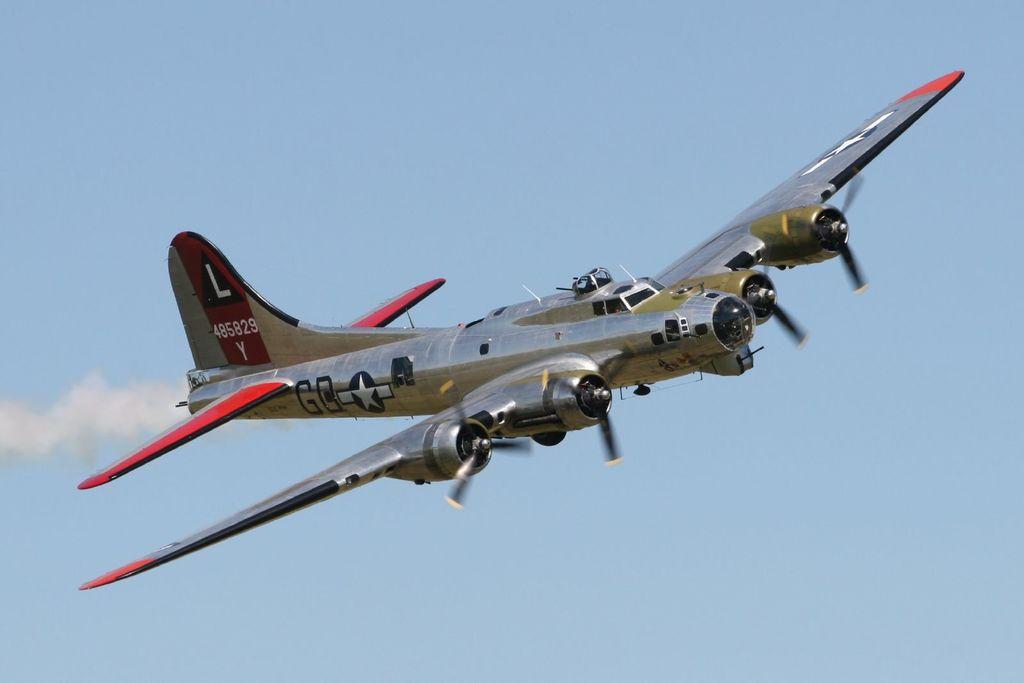What number is on the tail of this plane?
Offer a terse response. 485829. 